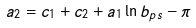Convert formula to latex. <formula><loc_0><loc_0><loc_500><loc_500>a _ { 2 } = c _ { 1 } + c _ { 2 } + a _ { 1 } \ln b _ { p s } - \pi</formula> 